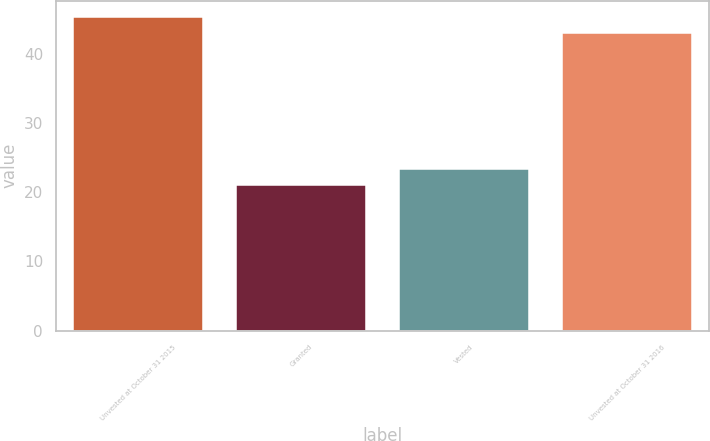Convert chart. <chart><loc_0><loc_0><loc_500><loc_500><bar_chart><fcel>Unvested at October 31 2015<fcel>Granted<fcel>Vested<fcel>Unvested at October 31 2016<nl><fcel>45.4<fcel>21<fcel>23.4<fcel>43<nl></chart> 